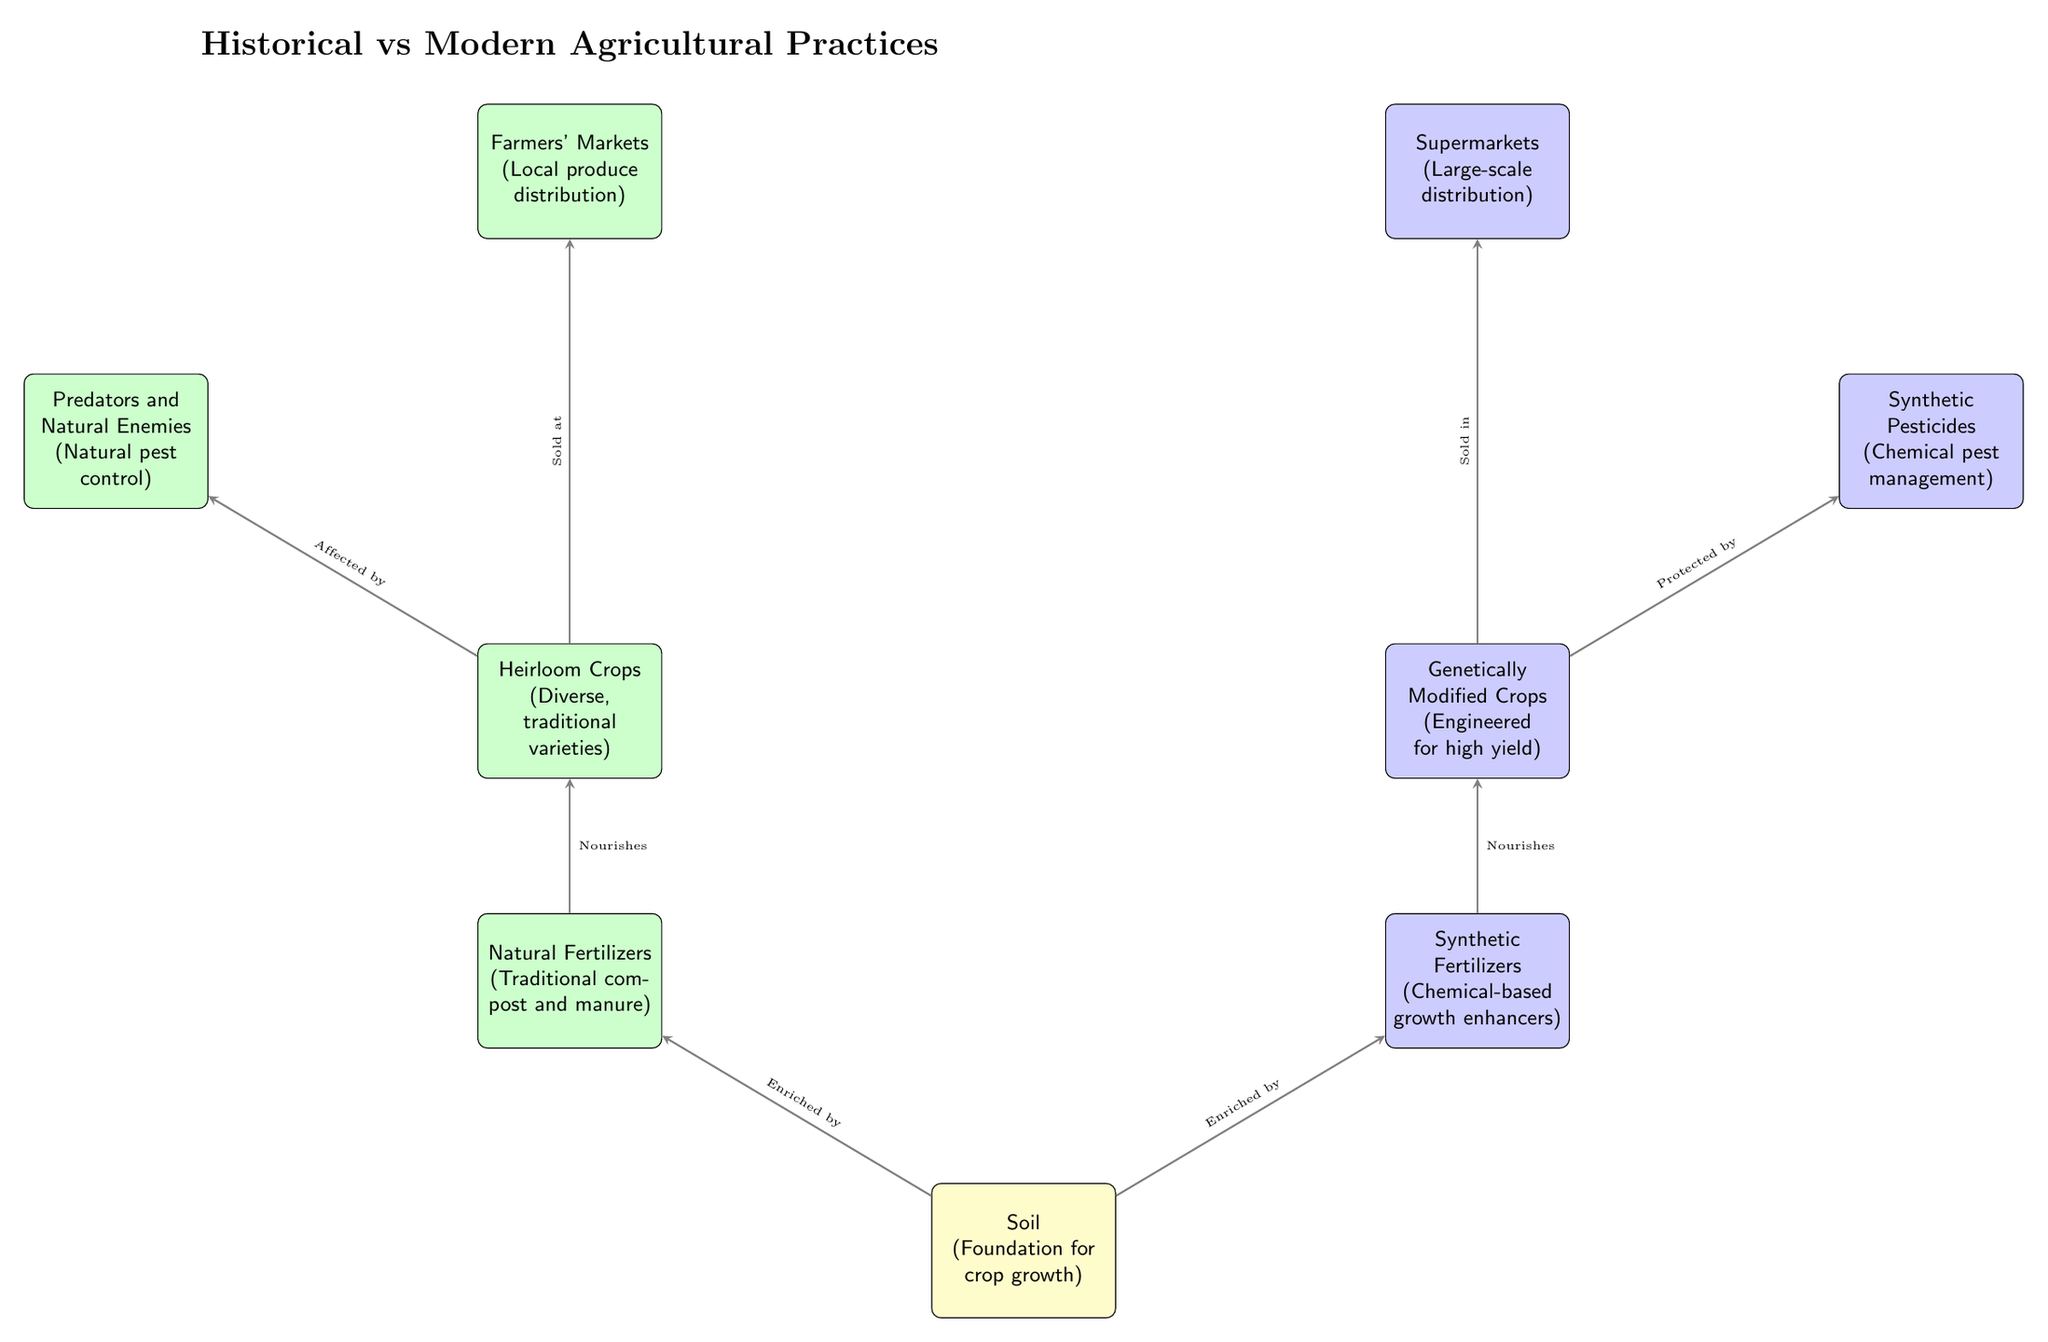What type of fertilizers are associated with historical practices? The diagram shows "Natural Fertilizers" as the type used in historical practices, which is represented in the green box labeled with traditional methods such as compost and manure above the soil.
Answer: Natural Fertilizers Which crops are noted in the modern agricultural practices? The modern practices indicate "Genetically Modified Crops," specified in the blue box below the pests management section. This type of crop is engineered for high yield.
Answer: Genetically Modified Crops What is the relationship between heirloom crops and pests in historical practices? The diagram indicates that "Heirloom Crops" are "Affected by" natural pest control methods, which shows a direct connection from the crops to the pest management system on the historical side.
Answer: Affected by Which market is related to modern agricultural practices? According to the diagram, "Supermarkets" are indicated as the type of market where modern agricultural products are sold, designated in the blue box below the modern crop section.
Answer: Supermarkets How many types of pest management are presented in the diagram? There are two types of pest management shown: "Predators and Natural Enemies" for historical practices and "Synthetic Pesticides" for modern practices. This involves counting the distinct pest management strategies depicted in the diagram.
Answer: Two What does soil feed into in the historical context? The diagram explains that soil "Enriched by" Natural Fertilizers leads directly to nourishing the "Heirloom Crops," showing the flow of nutrients in traditional practices.
Answer: Heirloom Crops What is the main difference in crop protection methods between historical and modern farming? The historical method uses "Predators and Natural Enemies" for pest control, while the modern method resorts to "Synthetic Pesticides," showcasing a significant shift in approach across practices.
Answer: Different methods Which process is implied for the crops in modern practices when it comes to distribution? The diagram implies that "Genetically Modified Crops" are "Sold in" Supermarkets, indicating the distribution approach for modern agricultural products.
Answer: Sold in Supermarkets 